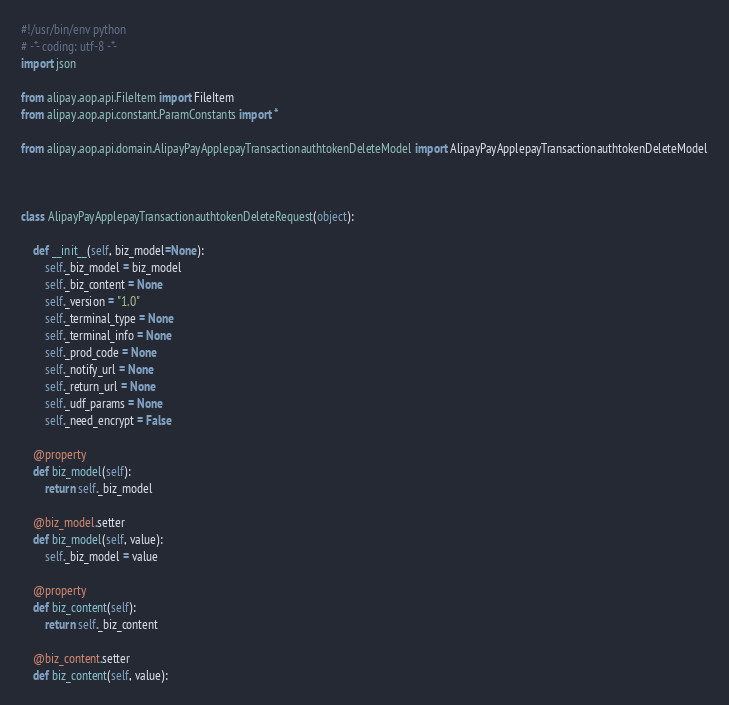Convert code to text. <code><loc_0><loc_0><loc_500><loc_500><_Python_>#!/usr/bin/env python
# -*- coding: utf-8 -*-
import json

from alipay.aop.api.FileItem import FileItem
from alipay.aop.api.constant.ParamConstants import *

from alipay.aop.api.domain.AlipayPayApplepayTransactionauthtokenDeleteModel import AlipayPayApplepayTransactionauthtokenDeleteModel



class AlipayPayApplepayTransactionauthtokenDeleteRequest(object):

    def __init__(self, biz_model=None):
        self._biz_model = biz_model
        self._biz_content = None
        self._version = "1.0"
        self._terminal_type = None
        self._terminal_info = None
        self._prod_code = None
        self._notify_url = None
        self._return_url = None
        self._udf_params = None
        self._need_encrypt = False

    @property
    def biz_model(self):
        return self._biz_model

    @biz_model.setter
    def biz_model(self, value):
        self._biz_model = value

    @property
    def biz_content(self):
        return self._biz_content

    @biz_content.setter
    def biz_content(self, value):</code> 